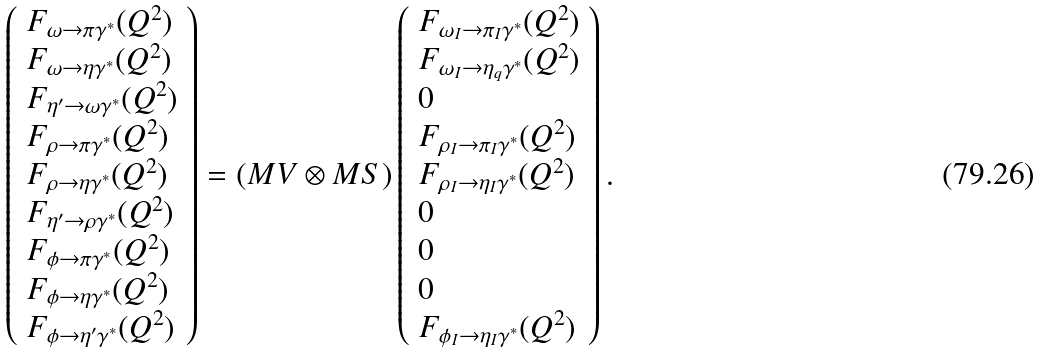<formula> <loc_0><loc_0><loc_500><loc_500>\left ( \begin{array} { l } F _ { \omega \rightarrow \pi \gamma ^ { * } } ( Q ^ { 2 } ) \\ F _ { \omega \rightarrow \eta \gamma ^ { * } } ( Q ^ { 2 } ) \\ F _ { \eta ^ { \prime } \rightarrow \omega \gamma ^ { * } } ( Q ^ { 2 } ) \\ F _ { \rho \rightarrow \pi \gamma ^ { * } } ( Q ^ { 2 } ) \\ F _ { \rho \rightarrow \eta \gamma ^ { * } } ( Q ^ { 2 } ) \\ F _ { \eta ^ { \prime } \rightarrow \rho \gamma ^ { * } } ( Q ^ { 2 } ) \\ F _ { \phi \rightarrow \pi \gamma ^ { * } } ( Q ^ { 2 } ) \\ F _ { \phi \rightarrow \eta \gamma ^ { * } } ( Q ^ { 2 } ) \\ F _ { \phi \rightarrow \eta ^ { \prime } \gamma ^ { * } } ( Q ^ { 2 } ) \end{array} \right ) = ( M V \otimes M S ) \left ( \begin{array} { l } F _ { \omega _ { I } \rightarrow \pi _ { I } \gamma ^ { * } } ( Q ^ { 2 } ) \\ F _ { \omega _ { I } \rightarrow \eta _ { q } \gamma ^ { * } } ( Q ^ { 2 } ) \\ 0 \\ F _ { \rho _ { I } \rightarrow \pi _ { I } \gamma ^ { * } } ( Q ^ { 2 } ) \\ F _ { \rho _ { I } \rightarrow \eta _ { I } \gamma ^ { * } } ( Q ^ { 2 } ) \\ 0 \\ 0 \\ 0 \\ F _ { \phi _ { I } \rightarrow \eta _ { I } \gamma ^ { * } } ( Q ^ { 2 } ) \end{array} \right ) .</formula> 